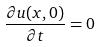<formula> <loc_0><loc_0><loc_500><loc_500>\frac { \partial u ( x , 0 ) } { \partial t } = 0</formula> 